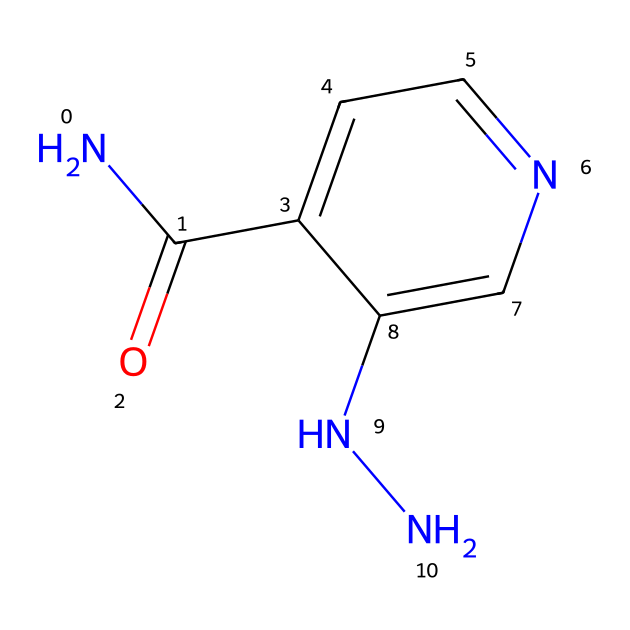What is the molecular formula of isoniazid? To find the molecular formula, count the number of each type of atom in the SMILES representation. The SMILES indicates 6 carbon (C), 7 hydrogen (H), 2 nitrogen (N), and 1 oxygen (O) atom, leading to the formula C6H7N3O.
Answer: C6H7N3O How many rings does isoniazid have? The SMILES representation shows a single cyclic structure (indicated by the 'c's), which means there is one ring in the molecule.
Answer: 1 What type of functional groups are present in isoniazid? Analyzing the SMILES, there is a carbonyl group (C=O) and an amine group (–NH). This indicates that isoniazid has both a carbonyl and a hydrazine functional group.
Answer: carbonyl and hydrazine Is isoniazid a polar compound? The presence of functional groups like the carbonyl and amine groups in isoniazid introduces polar characteristics, resulting in it being a polar compound due to its ability to form hydrogen bonds.
Answer: yes How many nitrogen atoms are in the hydrazine part of isoniazid? The hydrazine portion is identified at the end of the SMILES (NN), indicating there are two nitrogen (N) atoms present specifically within this hydrazine part of the structure.
Answer: 2 What is the primary use of isoniazid? The main purpose of isoniazid, as a hydrazine derivative, is to treat tuberculosis infections in urban clinics, highlighting its role in public health for managing this disease.
Answer: tuberculosis treatment Can isoniazid form hydrogen bonds? Yes, the presence of both an amine (–NH) and a carbonyl group (C=O) allows isoniazid to engage in hydrogen bonding interactions with other molecules, thus confirming it can form hydrogen bonds.
Answer: yes 